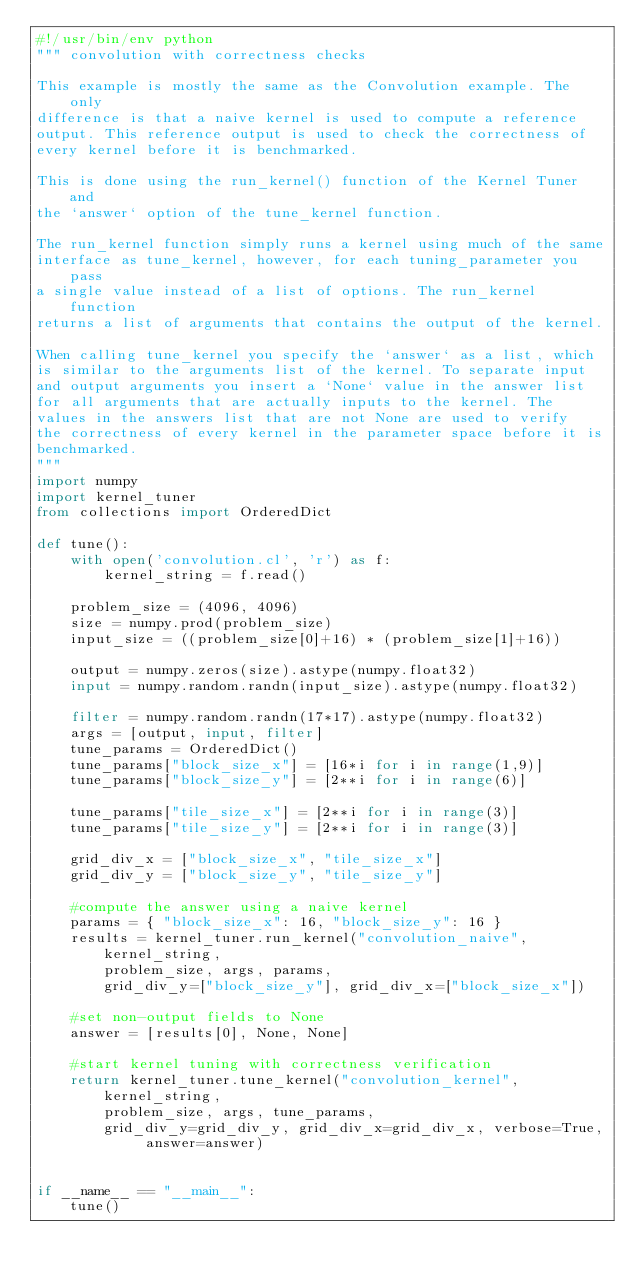Convert code to text. <code><loc_0><loc_0><loc_500><loc_500><_Python_>#!/usr/bin/env python
""" convolution with correctness checks

This example is mostly the same as the Convolution example. The only
difference is that a naive kernel is used to compute a reference
output. This reference output is used to check the correctness of
every kernel before it is benchmarked.

This is done using the run_kernel() function of the Kernel Tuner and
the `answer` option of the tune_kernel function.

The run_kernel function simply runs a kernel using much of the same
interface as tune_kernel, however, for each tuning_parameter you pass
a single value instead of a list of options. The run_kernel function
returns a list of arguments that contains the output of the kernel.

When calling tune_kernel you specify the `answer` as a list, which
is similar to the arguments list of the kernel. To separate input
and output arguments you insert a `None` value in the answer list
for all arguments that are actually inputs to the kernel. The
values in the answers list that are not None are used to verify
the correctness of every kernel in the parameter space before it is
benchmarked.
"""
import numpy
import kernel_tuner
from collections import OrderedDict

def tune():
    with open('convolution.cl', 'r') as f:
        kernel_string = f.read()

    problem_size = (4096, 4096)
    size = numpy.prod(problem_size)
    input_size = ((problem_size[0]+16) * (problem_size[1]+16))

    output = numpy.zeros(size).astype(numpy.float32)
    input = numpy.random.randn(input_size).astype(numpy.float32)

    filter = numpy.random.randn(17*17).astype(numpy.float32)
    args = [output, input, filter]
    tune_params = OrderedDict()
    tune_params["block_size_x"] = [16*i for i in range(1,9)]
    tune_params["block_size_y"] = [2**i for i in range(6)]

    tune_params["tile_size_x"] = [2**i for i in range(3)]
    tune_params["tile_size_y"] = [2**i for i in range(3)]

    grid_div_x = ["block_size_x", "tile_size_x"]
    grid_div_y = ["block_size_y", "tile_size_y"]

    #compute the answer using a naive kernel
    params = { "block_size_x": 16, "block_size_y": 16 }
    results = kernel_tuner.run_kernel("convolution_naive", kernel_string,
        problem_size, args, params,
        grid_div_y=["block_size_y"], grid_div_x=["block_size_x"])

    #set non-output fields to None
    answer = [results[0], None, None]

    #start kernel tuning with correctness verification
    return kernel_tuner.tune_kernel("convolution_kernel", kernel_string,
        problem_size, args, tune_params,
        grid_div_y=grid_div_y, grid_div_x=grid_div_x, verbose=True, answer=answer)


if __name__ == "__main__":
    tune()
</code> 